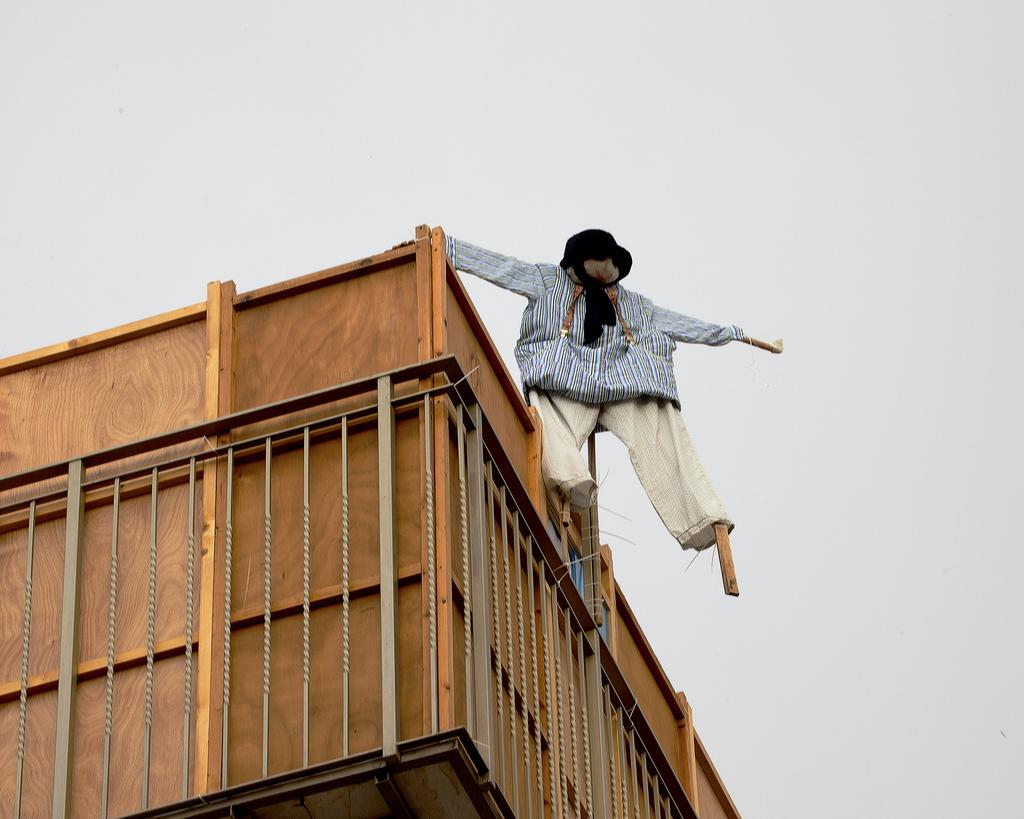What is the main subject in the image? There is a scarecrow in the image. How is the scarecrow supported or attached to something? The scarecrow is attached to a wooden object. What type of structure can be seen in the image? There is a fence in the image. What type of action is the scarecrow performing in the image? The scarecrow is not performing any action in the image; it is stationary and attached to a wooden object. Can you tell me the color of the scarecrow's neck in the image? There is no information about the color of the scarecrow's neck in the provided facts, and the image does not show the neck. 